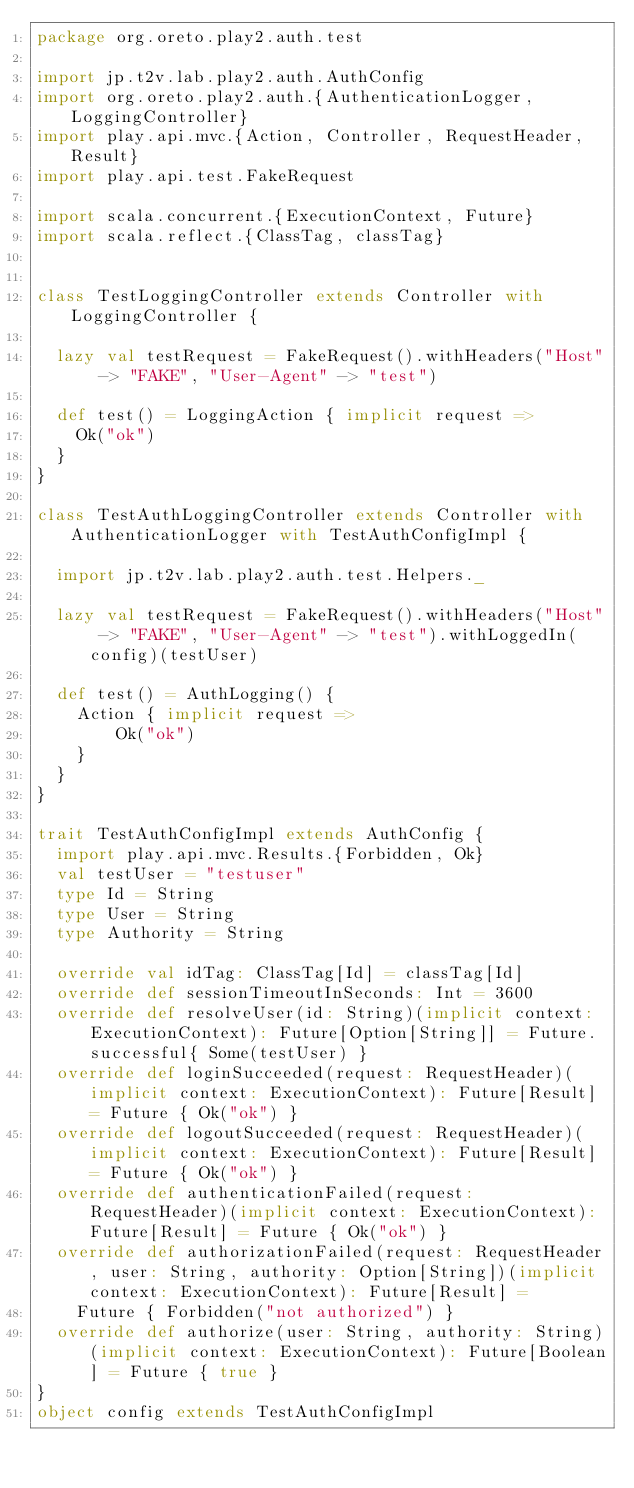Convert code to text. <code><loc_0><loc_0><loc_500><loc_500><_Scala_>package org.oreto.play2.auth.test

import jp.t2v.lab.play2.auth.AuthConfig
import org.oreto.play2.auth.{AuthenticationLogger, LoggingController}
import play.api.mvc.{Action, Controller, RequestHeader, Result}
import play.api.test.FakeRequest

import scala.concurrent.{ExecutionContext, Future}
import scala.reflect.{ClassTag, classTag}


class TestLoggingController extends Controller with LoggingController {

  lazy val testRequest = FakeRequest().withHeaders("Host" -> "FAKE", "User-Agent" -> "test")

  def test() = LoggingAction { implicit request =>
    Ok("ok")
  }
}

class TestAuthLoggingController extends Controller with AuthenticationLogger with TestAuthConfigImpl {

  import jp.t2v.lab.play2.auth.test.Helpers._

  lazy val testRequest = FakeRequest().withHeaders("Host" -> "FAKE", "User-Agent" -> "test").withLoggedIn(config)(testUser)

  def test() = AuthLogging() {
    Action { implicit request =>
        Ok("ok")
    }
  }
}

trait TestAuthConfigImpl extends AuthConfig {
  import play.api.mvc.Results.{Forbidden, Ok}
  val testUser = "testuser"
  type Id = String
  type User = String
  type Authority = String

  override val idTag: ClassTag[Id] = classTag[Id]
  override def sessionTimeoutInSeconds: Int = 3600
  override def resolveUser(id: String)(implicit context: ExecutionContext): Future[Option[String]] = Future.successful{ Some(testUser) }
  override def loginSucceeded(request: RequestHeader)(implicit context: ExecutionContext): Future[Result] = Future { Ok("ok") }
  override def logoutSucceeded(request: RequestHeader)(implicit context: ExecutionContext): Future[Result] = Future { Ok("ok") }
  override def authenticationFailed(request: RequestHeader)(implicit context: ExecutionContext): Future[Result] = Future { Ok("ok") }
  override def authorizationFailed(request: RequestHeader, user: String, authority: Option[String])(implicit context: ExecutionContext): Future[Result] =
    Future { Forbidden("not authorized") }
  override def authorize(user: String, authority: String)(implicit context: ExecutionContext): Future[Boolean] = Future { true }
}
object config extends TestAuthConfigImpl
</code> 